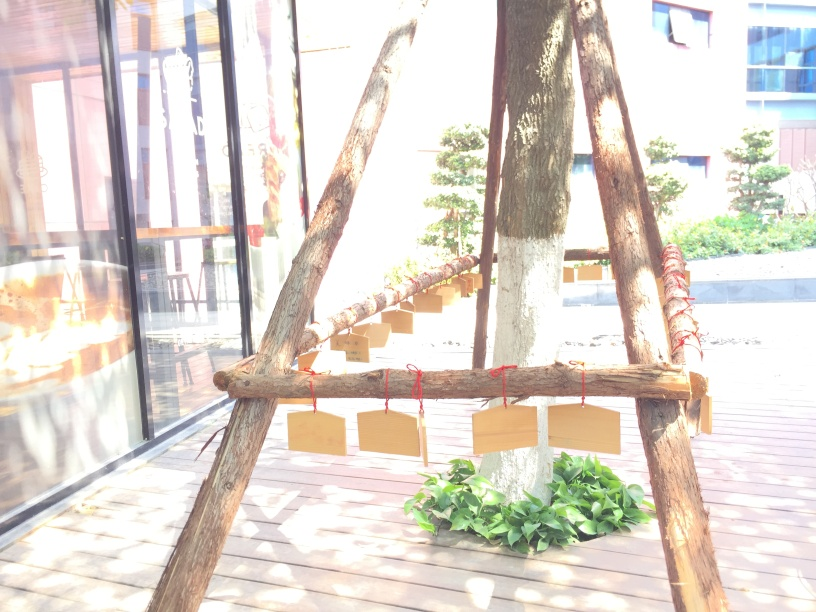Can you tell me what those hanging items are? It appears to be a series of wooden boards or plaques hung by red cords. They might be used for messages, signs, or decorative purposes, but it's unclear because the writing, if any, isn't visible due to the angle and exposure of the photo. 